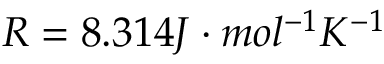Convert formula to latex. <formula><loc_0><loc_0><loc_500><loc_500>R = 8 . 3 1 4 J \cdot m o l ^ { - 1 } K ^ { - 1 }</formula> 